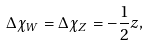<formula> <loc_0><loc_0><loc_500><loc_500>\Delta \chi _ { W } = \Delta \chi _ { Z } = - \frac { 1 } { 2 } z ,</formula> 